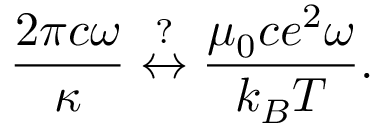<formula> <loc_0><loc_0><loc_500><loc_500>\frac { 2 \pi c \omega } { \kappa } \overset { ? } { \leftrightarrow } \frac { \mu _ { 0 } c e ^ { 2 } \omega } { k _ { B } T } .</formula> 